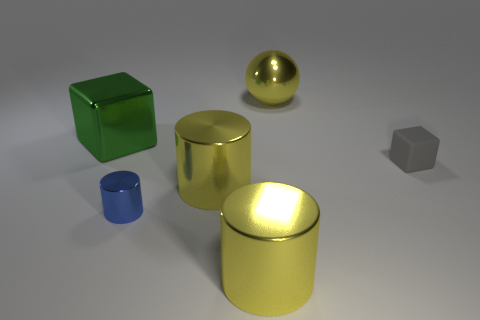What size is the shiny thing that is both behind the small blue cylinder and in front of the rubber block?
Ensure brevity in your answer.  Large. There is a cube that is right of the large yellow ball; is it the same color as the big object in front of the tiny shiny thing?
Keep it short and to the point. No. There is a small matte thing; how many cylinders are behind it?
Provide a short and direct response. 0. There is a tiny thing to the right of the big yellow metal thing that is behind the shiny cube; is there a blue cylinder that is on the right side of it?
Ensure brevity in your answer.  No. How many shiny spheres are the same size as the matte cube?
Offer a very short reply. 0. What is the thing behind the large green object that is behind the blue thing made of?
Provide a short and direct response. Metal. There is a big metallic object that is right of the yellow object in front of the blue metal object that is in front of the matte cube; what shape is it?
Provide a succinct answer. Sphere. There is a metallic thing that is behind the green cube; does it have the same shape as the small thing left of the big shiny ball?
Offer a very short reply. No. How many other things are there of the same material as the large green object?
Your answer should be compact. 4. What is the shape of the large green thing that is made of the same material as the small blue thing?
Ensure brevity in your answer.  Cube. 